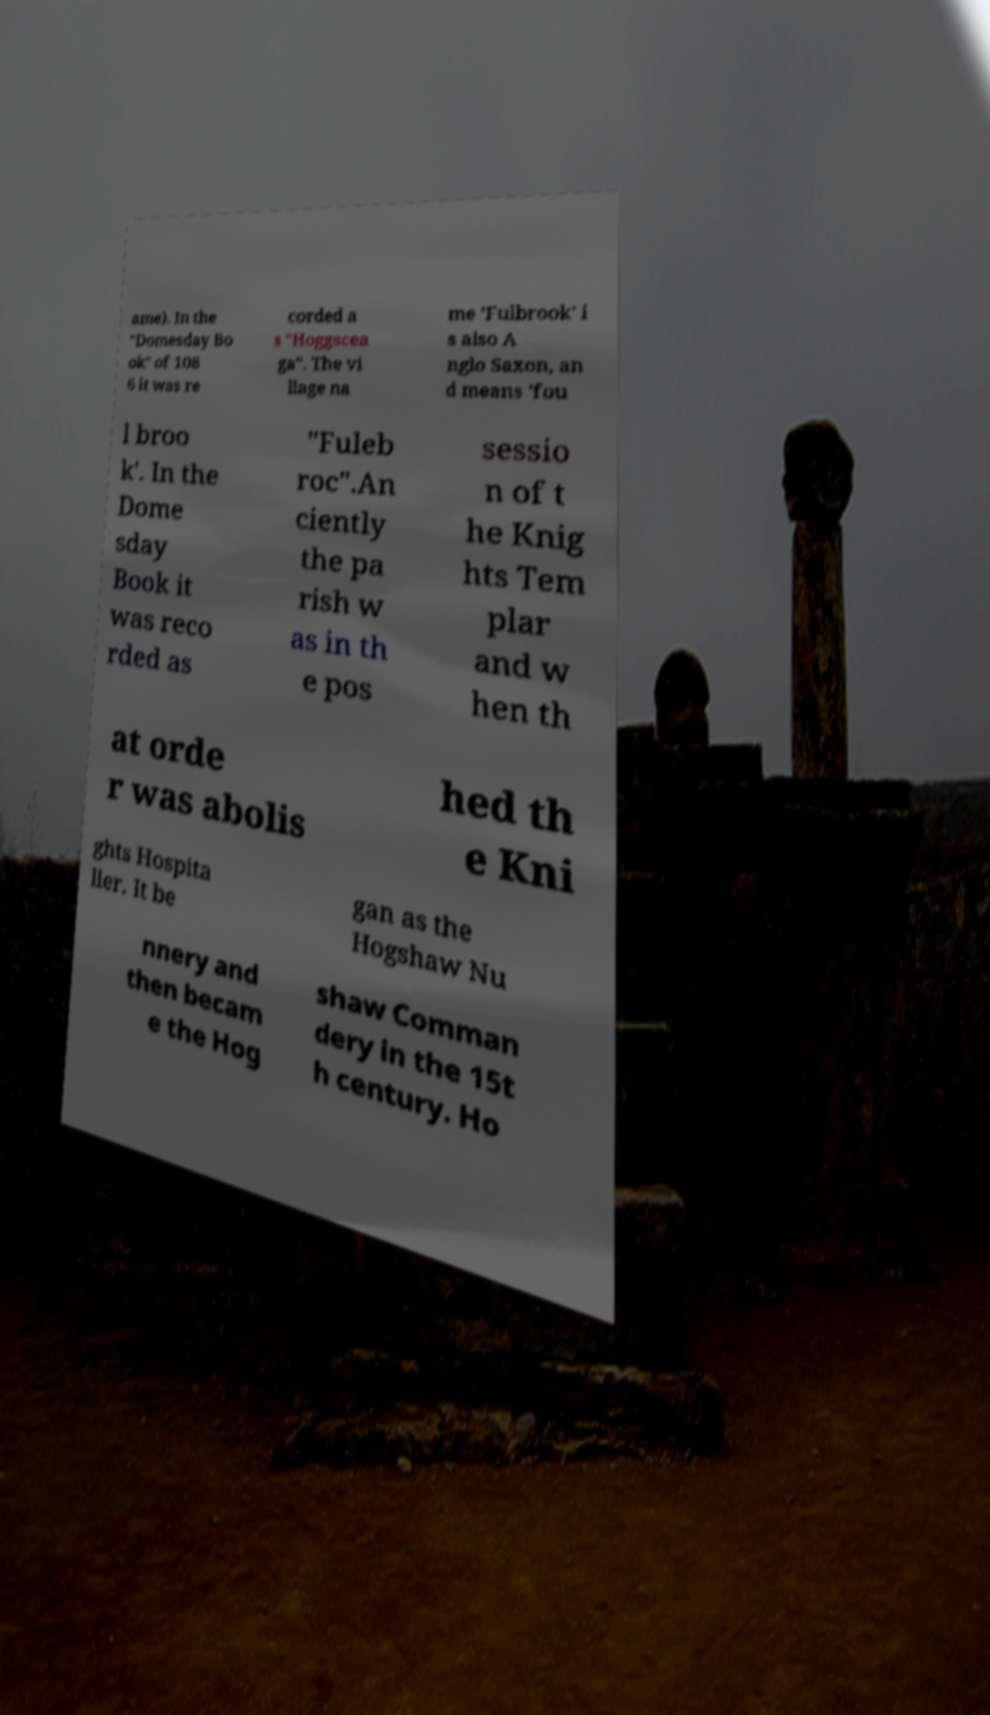What messages or text are displayed in this image? I need them in a readable, typed format. ame). In the "Domesday Bo ok" of 108 6 it was re corded a s "Hoggscea ga". The vi llage na me 'Fulbrook' i s also A nglo Saxon, an d means 'fou l broo k'. In the Dome sday Book it was reco rded as "Fuleb roc".An ciently the pa rish w as in th e pos sessio n of t he Knig hts Tem plar and w hen th at orde r was abolis hed th e Kni ghts Hospita ller. It be gan as the Hogshaw Nu nnery and then becam e the Hog shaw Comman dery in the 15t h century. Ho 